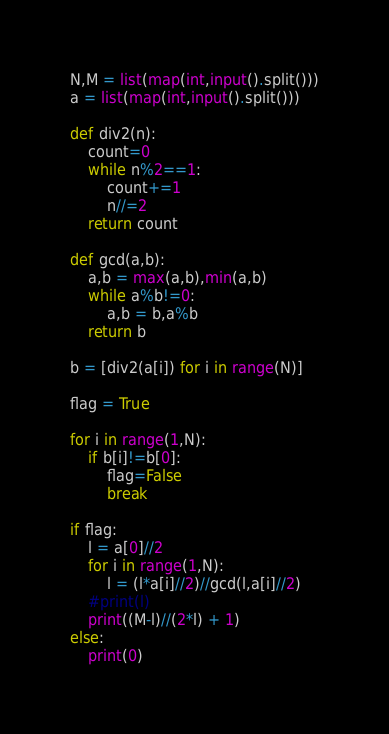<code> <loc_0><loc_0><loc_500><loc_500><_Python_>N,M = list(map(int,input().split()))
a = list(map(int,input().split()))

def div2(n):
    count=0
    while n%2==1:
        count+=1
        n//=2
    return count

def gcd(a,b):
    a,b = max(a,b),min(a,b)
    while a%b!=0:
        a,b = b,a%b
    return b

b = [div2(a[i]) for i in range(N)]

flag = True

for i in range(1,N):
    if b[i]!=b[0]:
        flag=False
        break

if flag:
    l = a[0]//2
    for i in range(1,N):
        l = (l*a[i]//2)//gcd(l,a[i]//2)
    #print(l)
    print((M-l)//(2*l) + 1)
else:
    print(0)</code> 